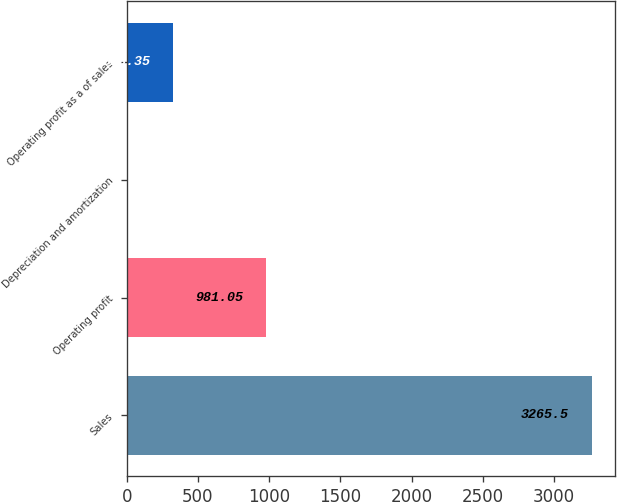<chart> <loc_0><loc_0><loc_500><loc_500><bar_chart><fcel>Sales<fcel>Operating profit<fcel>Depreciation and amortization<fcel>Operating profit as a of sales<nl><fcel>3265.5<fcel>981.05<fcel>2<fcel>328.35<nl></chart> 